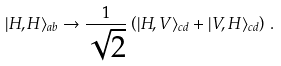Convert formula to latex. <formula><loc_0><loc_0><loc_500><loc_500>| H , H \rangle _ { a b } \rightarrow \frac { 1 } { \sqrt { 2 } } \left ( | H , V \rangle _ { c d } + | V , H \rangle _ { c d } \right ) \, .</formula> 